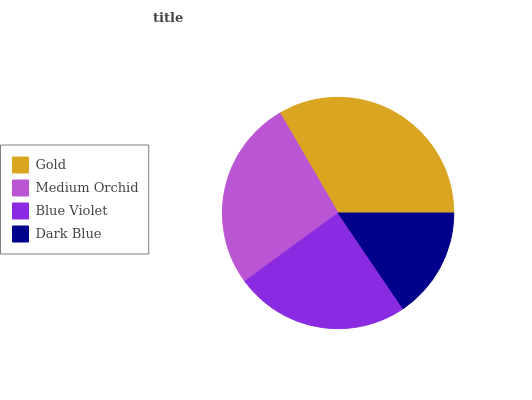Is Dark Blue the minimum?
Answer yes or no. Yes. Is Gold the maximum?
Answer yes or no. Yes. Is Medium Orchid the minimum?
Answer yes or no. No. Is Medium Orchid the maximum?
Answer yes or no. No. Is Gold greater than Medium Orchid?
Answer yes or no. Yes. Is Medium Orchid less than Gold?
Answer yes or no. Yes. Is Medium Orchid greater than Gold?
Answer yes or no. No. Is Gold less than Medium Orchid?
Answer yes or no. No. Is Medium Orchid the high median?
Answer yes or no. Yes. Is Blue Violet the low median?
Answer yes or no. Yes. Is Gold the high median?
Answer yes or no. No. Is Gold the low median?
Answer yes or no. No. 